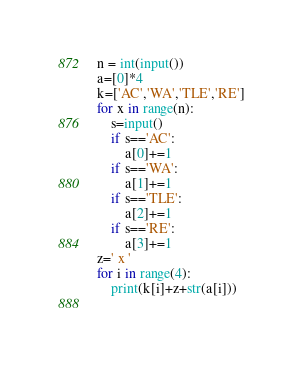<code> <loc_0><loc_0><loc_500><loc_500><_Python_>n = int(input())
a=[0]*4
k=['AC','WA','TLE','RE']
for x in range(n):
    s=input()
    if s=='AC':
        a[0]+=1
    if s=='WA':
        a[1]+=1
    if s=='TLE':
        a[2]+=1
    if s=='RE':
        a[3]+=1
z=' x '
for i in range(4):
    print(k[i]+z+str(a[i]))
    
</code> 